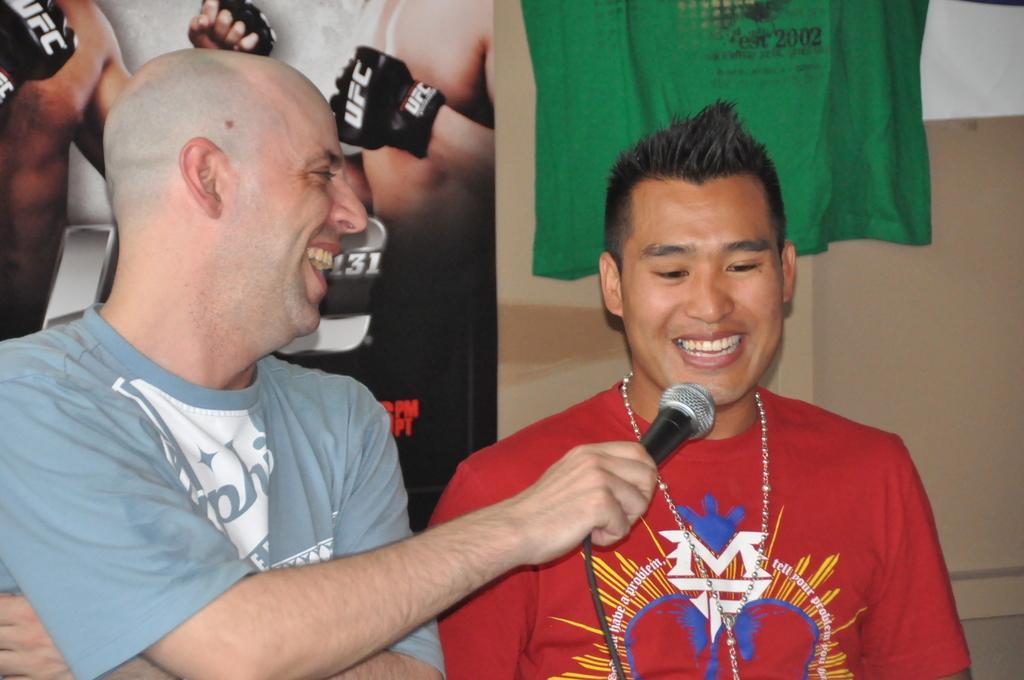Describe this image in one or two sentences. In this image in the foreground there are two men one person is holding a mike and talking, and in the background there is a cloth, wall and board. On the board there is an image of two persons, and some text. 